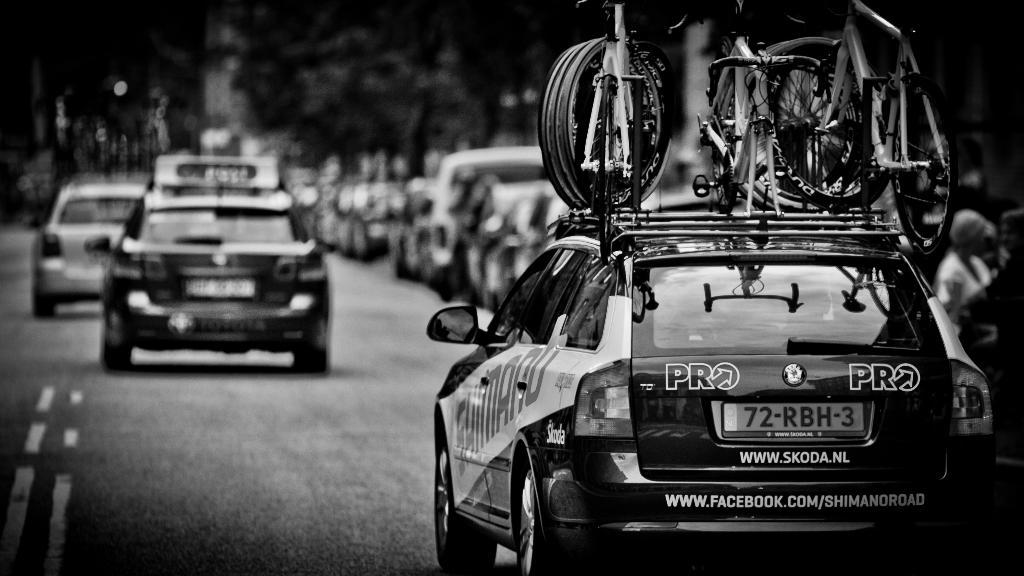What is the color scheme of the image? The image is black and white. What can be seen on the road in the image? There are vehicles on the road in the image. What is an unusual detail about the vehicles in the image? There are bicycles on a car in the image. How would you describe the background of the image? The background of the image is blurred. What type of nerve can be seen in the image? There is no nerve present in the image; it features vehicles on the road and a car with bicycles. 